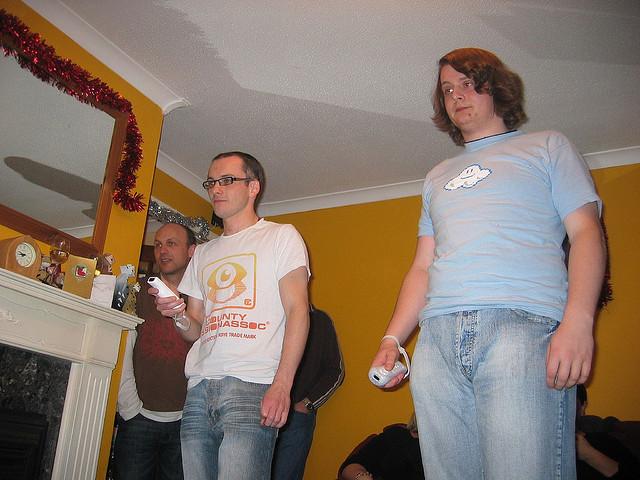What the men doing standing and holding controls?
Write a very short answer. Playing wii. Are they singing?
Give a very brief answer. No. Why has he raised his hand?
Keep it brief. Playing wii. Is one of the men wearing yellow?
Answer briefly. Yes. 